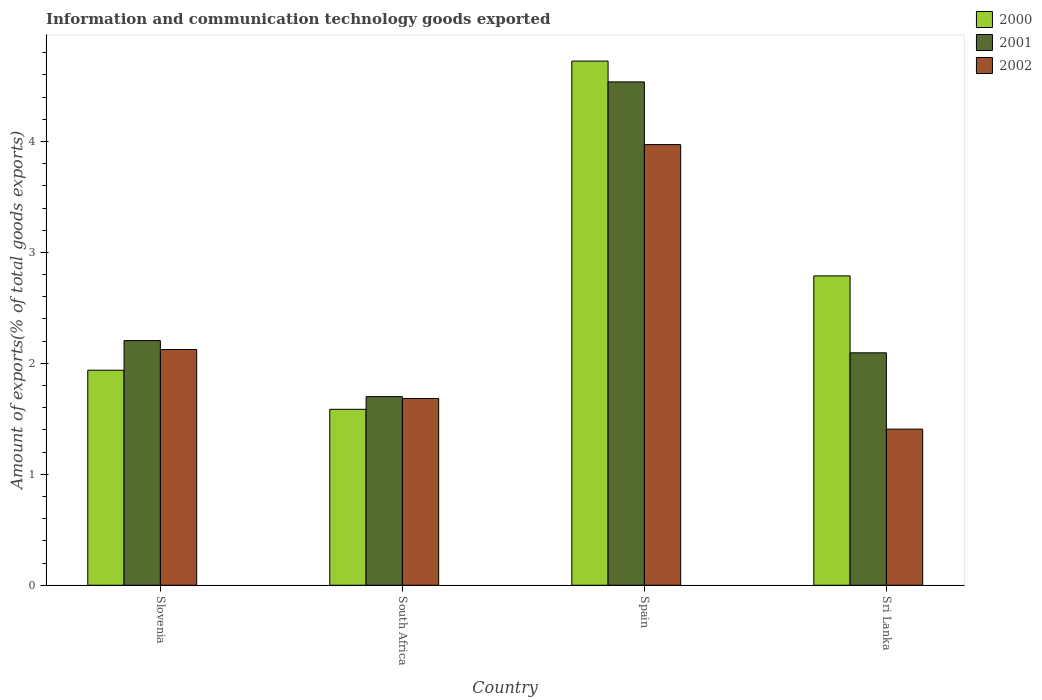Are the number of bars per tick equal to the number of legend labels?
Your response must be concise. Yes. How many bars are there on the 4th tick from the right?
Your answer should be compact. 3. What is the label of the 2nd group of bars from the left?
Your response must be concise. South Africa. What is the amount of goods exported in 2000 in Spain?
Offer a terse response. 4.72. Across all countries, what is the maximum amount of goods exported in 2002?
Your answer should be compact. 3.97. Across all countries, what is the minimum amount of goods exported in 2002?
Keep it short and to the point. 1.41. In which country was the amount of goods exported in 2002 minimum?
Offer a terse response. Sri Lanka. What is the total amount of goods exported in 2002 in the graph?
Offer a terse response. 9.19. What is the difference between the amount of goods exported in 2000 in Slovenia and that in Sri Lanka?
Offer a terse response. -0.85. What is the difference between the amount of goods exported in 2000 in Slovenia and the amount of goods exported in 2002 in Spain?
Give a very brief answer. -2.03. What is the average amount of goods exported in 2002 per country?
Provide a short and direct response. 2.3. What is the difference between the amount of goods exported of/in 2001 and amount of goods exported of/in 2002 in South Africa?
Offer a terse response. 0.02. What is the ratio of the amount of goods exported in 2000 in Slovenia to that in South Africa?
Your answer should be very brief. 1.22. Is the amount of goods exported in 2001 in Slovenia less than that in Spain?
Give a very brief answer. Yes. Is the difference between the amount of goods exported in 2001 in South Africa and Sri Lanka greater than the difference between the amount of goods exported in 2002 in South Africa and Sri Lanka?
Provide a succinct answer. No. What is the difference between the highest and the second highest amount of goods exported in 2002?
Provide a succinct answer. -0.44. What is the difference between the highest and the lowest amount of goods exported in 2000?
Make the answer very short. 3.14. In how many countries, is the amount of goods exported in 2000 greater than the average amount of goods exported in 2000 taken over all countries?
Ensure brevity in your answer.  2. Is the sum of the amount of goods exported in 2001 in Slovenia and Sri Lanka greater than the maximum amount of goods exported in 2002 across all countries?
Keep it short and to the point. Yes. What does the 3rd bar from the left in Sri Lanka represents?
Make the answer very short. 2002. Are all the bars in the graph horizontal?
Your answer should be compact. No. How many countries are there in the graph?
Make the answer very short. 4. Does the graph contain any zero values?
Provide a short and direct response. No. Does the graph contain grids?
Your response must be concise. No. Where does the legend appear in the graph?
Keep it short and to the point. Top right. What is the title of the graph?
Ensure brevity in your answer.  Information and communication technology goods exported. Does "1965" appear as one of the legend labels in the graph?
Provide a succinct answer. No. What is the label or title of the Y-axis?
Make the answer very short. Amount of exports(% of total goods exports). What is the Amount of exports(% of total goods exports) of 2000 in Slovenia?
Provide a succinct answer. 1.94. What is the Amount of exports(% of total goods exports) of 2001 in Slovenia?
Make the answer very short. 2.21. What is the Amount of exports(% of total goods exports) in 2002 in Slovenia?
Your response must be concise. 2.12. What is the Amount of exports(% of total goods exports) of 2000 in South Africa?
Ensure brevity in your answer.  1.59. What is the Amount of exports(% of total goods exports) in 2001 in South Africa?
Make the answer very short. 1.7. What is the Amount of exports(% of total goods exports) in 2002 in South Africa?
Your answer should be compact. 1.68. What is the Amount of exports(% of total goods exports) in 2000 in Spain?
Offer a very short reply. 4.72. What is the Amount of exports(% of total goods exports) in 2001 in Spain?
Your answer should be compact. 4.54. What is the Amount of exports(% of total goods exports) of 2002 in Spain?
Provide a short and direct response. 3.97. What is the Amount of exports(% of total goods exports) in 2000 in Sri Lanka?
Keep it short and to the point. 2.79. What is the Amount of exports(% of total goods exports) of 2001 in Sri Lanka?
Keep it short and to the point. 2.1. What is the Amount of exports(% of total goods exports) of 2002 in Sri Lanka?
Your response must be concise. 1.41. Across all countries, what is the maximum Amount of exports(% of total goods exports) of 2000?
Keep it short and to the point. 4.72. Across all countries, what is the maximum Amount of exports(% of total goods exports) in 2001?
Your answer should be very brief. 4.54. Across all countries, what is the maximum Amount of exports(% of total goods exports) of 2002?
Give a very brief answer. 3.97. Across all countries, what is the minimum Amount of exports(% of total goods exports) of 2000?
Make the answer very short. 1.59. Across all countries, what is the minimum Amount of exports(% of total goods exports) in 2001?
Your answer should be compact. 1.7. Across all countries, what is the minimum Amount of exports(% of total goods exports) of 2002?
Your answer should be very brief. 1.41. What is the total Amount of exports(% of total goods exports) in 2000 in the graph?
Your answer should be compact. 11.04. What is the total Amount of exports(% of total goods exports) of 2001 in the graph?
Your response must be concise. 10.54. What is the total Amount of exports(% of total goods exports) of 2002 in the graph?
Your answer should be compact. 9.19. What is the difference between the Amount of exports(% of total goods exports) of 2000 in Slovenia and that in South Africa?
Offer a terse response. 0.35. What is the difference between the Amount of exports(% of total goods exports) in 2001 in Slovenia and that in South Africa?
Offer a terse response. 0.51. What is the difference between the Amount of exports(% of total goods exports) in 2002 in Slovenia and that in South Africa?
Provide a short and direct response. 0.44. What is the difference between the Amount of exports(% of total goods exports) of 2000 in Slovenia and that in Spain?
Offer a terse response. -2.79. What is the difference between the Amount of exports(% of total goods exports) in 2001 in Slovenia and that in Spain?
Keep it short and to the point. -2.33. What is the difference between the Amount of exports(% of total goods exports) of 2002 in Slovenia and that in Spain?
Offer a terse response. -1.85. What is the difference between the Amount of exports(% of total goods exports) of 2000 in Slovenia and that in Sri Lanka?
Your answer should be very brief. -0.85. What is the difference between the Amount of exports(% of total goods exports) of 2001 in Slovenia and that in Sri Lanka?
Provide a short and direct response. 0.11. What is the difference between the Amount of exports(% of total goods exports) of 2002 in Slovenia and that in Sri Lanka?
Offer a very short reply. 0.72. What is the difference between the Amount of exports(% of total goods exports) of 2000 in South Africa and that in Spain?
Your answer should be compact. -3.14. What is the difference between the Amount of exports(% of total goods exports) in 2001 in South Africa and that in Spain?
Your answer should be compact. -2.84. What is the difference between the Amount of exports(% of total goods exports) in 2002 in South Africa and that in Spain?
Offer a very short reply. -2.29. What is the difference between the Amount of exports(% of total goods exports) of 2000 in South Africa and that in Sri Lanka?
Your answer should be compact. -1.2. What is the difference between the Amount of exports(% of total goods exports) of 2001 in South Africa and that in Sri Lanka?
Make the answer very short. -0.4. What is the difference between the Amount of exports(% of total goods exports) in 2002 in South Africa and that in Sri Lanka?
Provide a succinct answer. 0.28. What is the difference between the Amount of exports(% of total goods exports) in 2000 in Spain and that in Sri Lanka?
Your response must be concise. 1.94. What is the difference between the Amount of exports(% of total goods exports) of 2001 in Spain and that in Sri Lanka?
Provide a short and direct response. 2.44. What is the difference between the Amount of exports(% of total goods exports) of 2002 in Spain and that in Sri Lanka?
Offer a terse response. 2.56. What is the difference between the Amount of exports(% of total goods exports) in 2000 in Slovenia and the Amount of exports(% of total goods exports) in 2001 in South Africa?
Your answer should be compact. 0.24. What is the difference between the Amount of exports(% of total goods exports) in 2000 in Slovenia and the Amount of exports(% of total goods exports) in 2002 in South Africa?
Offer a terse response. 0.25. What is the difference between the Amount of exports(% of total goods exports) of 2001 in Slovenia and the Amount of exports(% of total goods exports) of 2002 in South Africa?
Your answer should be very brief. 0.52. What is the difference between the Amount of exports(% of total goods exports) in 2000 in Slovenia and the Amount of exports(% of total goods exports) in 2001 in Spain?
Give a very brief answer. -2.6. What is the difference between the Amount of exports(% of total goods exports) of 2000 in Slovenia and the Amount of exports(% of total goods exports) of 2002 in Spain?
Your response must be concise. -2.03. What is the difference between the Amount of exports(% of total goods exports) of 2001 in Slovenia and the Amount of exports(% of total goods exports) of 2002 in Spain?
Ensure brevity in your answer.  -1.77. What is the difference between the Amount of exports(% of total goods exports) of 2000 in Slovenia and the Amount of exports(% of total goods exports) of 2001 in Sri Lanka?
Give a very brief answer. -0.16. What is the difference between the Amount of exports(% of total goods exports) of 2000 in Slovenia and the Amount of exports(% of total goods exports) of 2002 in Sri Lanka?
Offer a terse response. 0.53. What is the difference between the Amount of exports(% of total goods exports) in 2001 in Slovenia and the Amount of exports(% of total goods exports) in 2002 in Sri Lanka?
Offer a terse response. 0.8. What is the difference between the Amount of exports(% of total goods exports) of 2000 in South Africa and the Amount of exports(% of total goods exports) of 2001 in Spain?
Provide a short and direct response. -2.95. What is the difference between the Amount of exports(% of total goods exports) in 2000 in South Africa and the Amount of exports(% of total goods exports) in 2002 in Spain?
Offer a very short reply. -2.39. What is the difference between the Amount of exports(% of total goods exports) of 2001 in South Africa and the Amount of exports(% of total goods exports) of 2002 in Spain?
Make the answer very short. -2.27. What is the difference between the Amount of exports(% of total goods exports) in 2000 in South Africa and the Amount of exports(% of total goods exports) in 2001 in Sri Lanka?
Your answer should be very brief. -0.51. What is the difference between the Amount of exports(% of total goods exports) of 2000 in South Africa and the Amount of exports(% of total goods exports) of 2002 in Sri Lanka?
Provide a succinct answer. 0.18. What is the difference between the Amount of exports(% of total goods exports) in 2001 in South Africa and the Amount of exports(% of total goods exports) in 2002 in Sri Lanka?
Ensure brevity in your answer.  0.29. What is the difference between the Amount of exports(% of total goods exports) in 2000 in Spain and the Amount of exports(% of total goods exports) in 2001 in Sri Lanka?
Offer a very short reply. 2.63. What is the difference between the Amount of exports(% of total goods exports) of 2000 in Spain and the Amount of exports(% of total goods exports) of 2002 in Sri Lanka?
Your answer should be compact. 3.32. What is the difference between the Amount of exports(% of total goods exports) in 2001 in Spain and the Amount of exports(% of total goods exports) in 2002 in Sri Lanka?
Your response must be concise. 3.13. What is the average Amount of exports(% of total goods exports) in 2000 per country?
Your response must be concise. 2.76. What is the average Amount of exports(% of total goods exports) in 2001 per country?
Your answer should be very brief. 2.63. What is the average Amount of exports(% of total goods exports) in 2002 per country?
Give a very brief answer. 2.3. What is the difference between the Amount of exports(% of total goods exports) of 2000 and Amount of exports(% of total goods exports) of 2001 in Slovenia?
Give a very brief answer. -0.27. What is the difference between the Amount of exports(% of total goods exports) in 2000 and Amount of exports(% of total goods exports) in 2002 in Slovenia?
Give a very brief answer. -0.19. What is the difference between the Amount of exports(% of total goods exports) of 2001 and Amount of exports(% of total goods exports) of 2002 in Slovenia?
Offer a very short reply. 0.08. What is the difference between the Amount of exports(% of total goods exports) in 2000 and Amount of exports(% of total goods exports) in 2001 in South Africa?
Offer a terse response. -0.11. What is the difference between the Amount of exports(% of total goods exports) in 2000 and Amount of exports(% of total goods exports) in 2002 in South Africa?
Offer a terse response. -0.1. What is the difference between the Amount of exports(% of total goods exports) in 2001 and Amount of exports(% of total goods exports) in 2002 in South Africa?
Offer a terse response. 0.02. What is the difference between the Amount of exports(% of total goods exports) in 2000 and Amount of exports(% of total goods exports) in 2001 in Spain?
Provide a short and direct response. 0.19. What is the difference between the Amount of exports(% of total goods exports) in 2000 and Amount of exports(% of total goods exports) in 2002 in Spain?
Your answer should be very brief. 0.75. What is the difference between the Amount of exports(% of total goods exports) of 2001 and Amount of exports(% of total goods exports) of 2002 in Spain?
Provide a succinct answer. 0.57. What is the difference between the Amount of exports(% of total goods exports) in 2000 and Amount of exports(% of total goods exports) in 2001 in Sri Lanka?
Your answer should be very brief. 0.69. What is the difference between the Amount of exports(% of total goods exports) in 2000 and Amount of exports(% of total goods exports) in 2002 in Sri Lanka?
Provide a short and direct response. 1.38. What is the difference between the Amount of exports(% of total goods exports) of 2001 and Amount of exports(% of total goods exports) of 2002 in Sri Lanka?
Provide a short and direct response. 0.69. What is the ratio of the Amount of exports(% of total goods exports) of 2000 in Slovenia to that in South Africa?
Make the answer very short. 1.22. What is the ratio of the Amount of exports(% of total goods exports) in 2001 in Slovenia to that in South Africa?
Provide a short and direct response. 1.3. What is the ratio of the Amount of exports(% of total goods exports) in 2002 in Slovenia to that in South Africa?
Give a very brief answer. 1.26. What is the ratio of the Amount of exports(% of total goods exports) in 2000 in Slovenia to that in Spain?
Keep it short and to the point. 0.41. What is the ratio of the Amount of exports(% of total goods exports) of 2001 in Slovenia to that in Spain?
Ensure brevity in your answer.  0.49. What is the ratio of the Amount of exports(% of total goods exports) of 2002 in Slovenia to that in Spain?
Offer a terse response. 0.53. What is the ratio of the Amount of exports(% of total goods exports) of 2000 in Slovenia to that in Sri Lanka?
Your response must be concise. 0.7. What is the ratio of the Amount of exports(% of total goods exports) in 2001 in Slovenia to that in Sri Lanka?
Keep it short and to the point. 1.05. What is the ratio of the Amount of exports(% of total goods exports) of 2002 in Slovenia to that in Sri Lanka?
Provide a succinct answer. 1.51. What is the ratio of the Amount of exports(% of total goods exports) of 2000 in South Africa to that in Spain?
Give a very brief answer. 0.34. What is the ratio of the Amount of exports(% of total goods exports) of 2001 in South Africa to that in Spain?
Offer a very short reply. 0.37. What is the ratio of the Amount of exports(% of total goods exports) in 2002 in South Africa to that in Spain?
Offer a terse response. 0.42. What is the ratio of the Amount of exports(% of total goods exports) in 2000 in South Africa to that in Sri Lanka?
Offer a terse response. 0.57. What is the ratio of the Amount of exports(% of total goods exports) in 2001 in South Africa to that in Sri Lanka?
Ensure brevity in your answer.  0.81. What is the ratio of the Amount of exports(% of total goods exports) in 2002 in South Africa to that in Sri Lanka?
Offer a terse response. 1.2. What is the ratio of the Amount of exports(% of total goods exports) in 2000 in Spain to that in Sri Lanka?
Give a very brief answer. 1.69. What is the ratio of the Amount of exports(% of total goods exports) in 2001 in Spain to that in Sri Lanka?
Give a very brief answer. 2.17. What is the ratio of the Amount of exports(% of total goods exports) of 2002 in Spain to that in Sri Lanka?
Provide a short and direct response. 2.82. What is the difference between the highest and the second highest Amount of exports(% of total goods exports) of 2000?
Your answer should be very brief. 1.94. What is the difference between the highest and the second highest Amount of exports(% of total goods exports) in 2001?
Keep it short and to the point. 2.33. What is the difference between the highest and the second highest Amount of exports(% of total goods exports) of 2002?
Your answer should be very brief. 1.85. What is the difference between the highest and the lowest Amount of exports(% of total goods exports) in 2000?
Keep it short and to the point. 3.14. What is the difference between the highest and the lowest Amount of exports(% of total goods exports) in 2001?
Ensure brevity in your answer.  2.84. What is the difference between the highest and the lowest Amount of exports(% of total goods exports) in 2002?
Offer a very short reply. 2.56. 